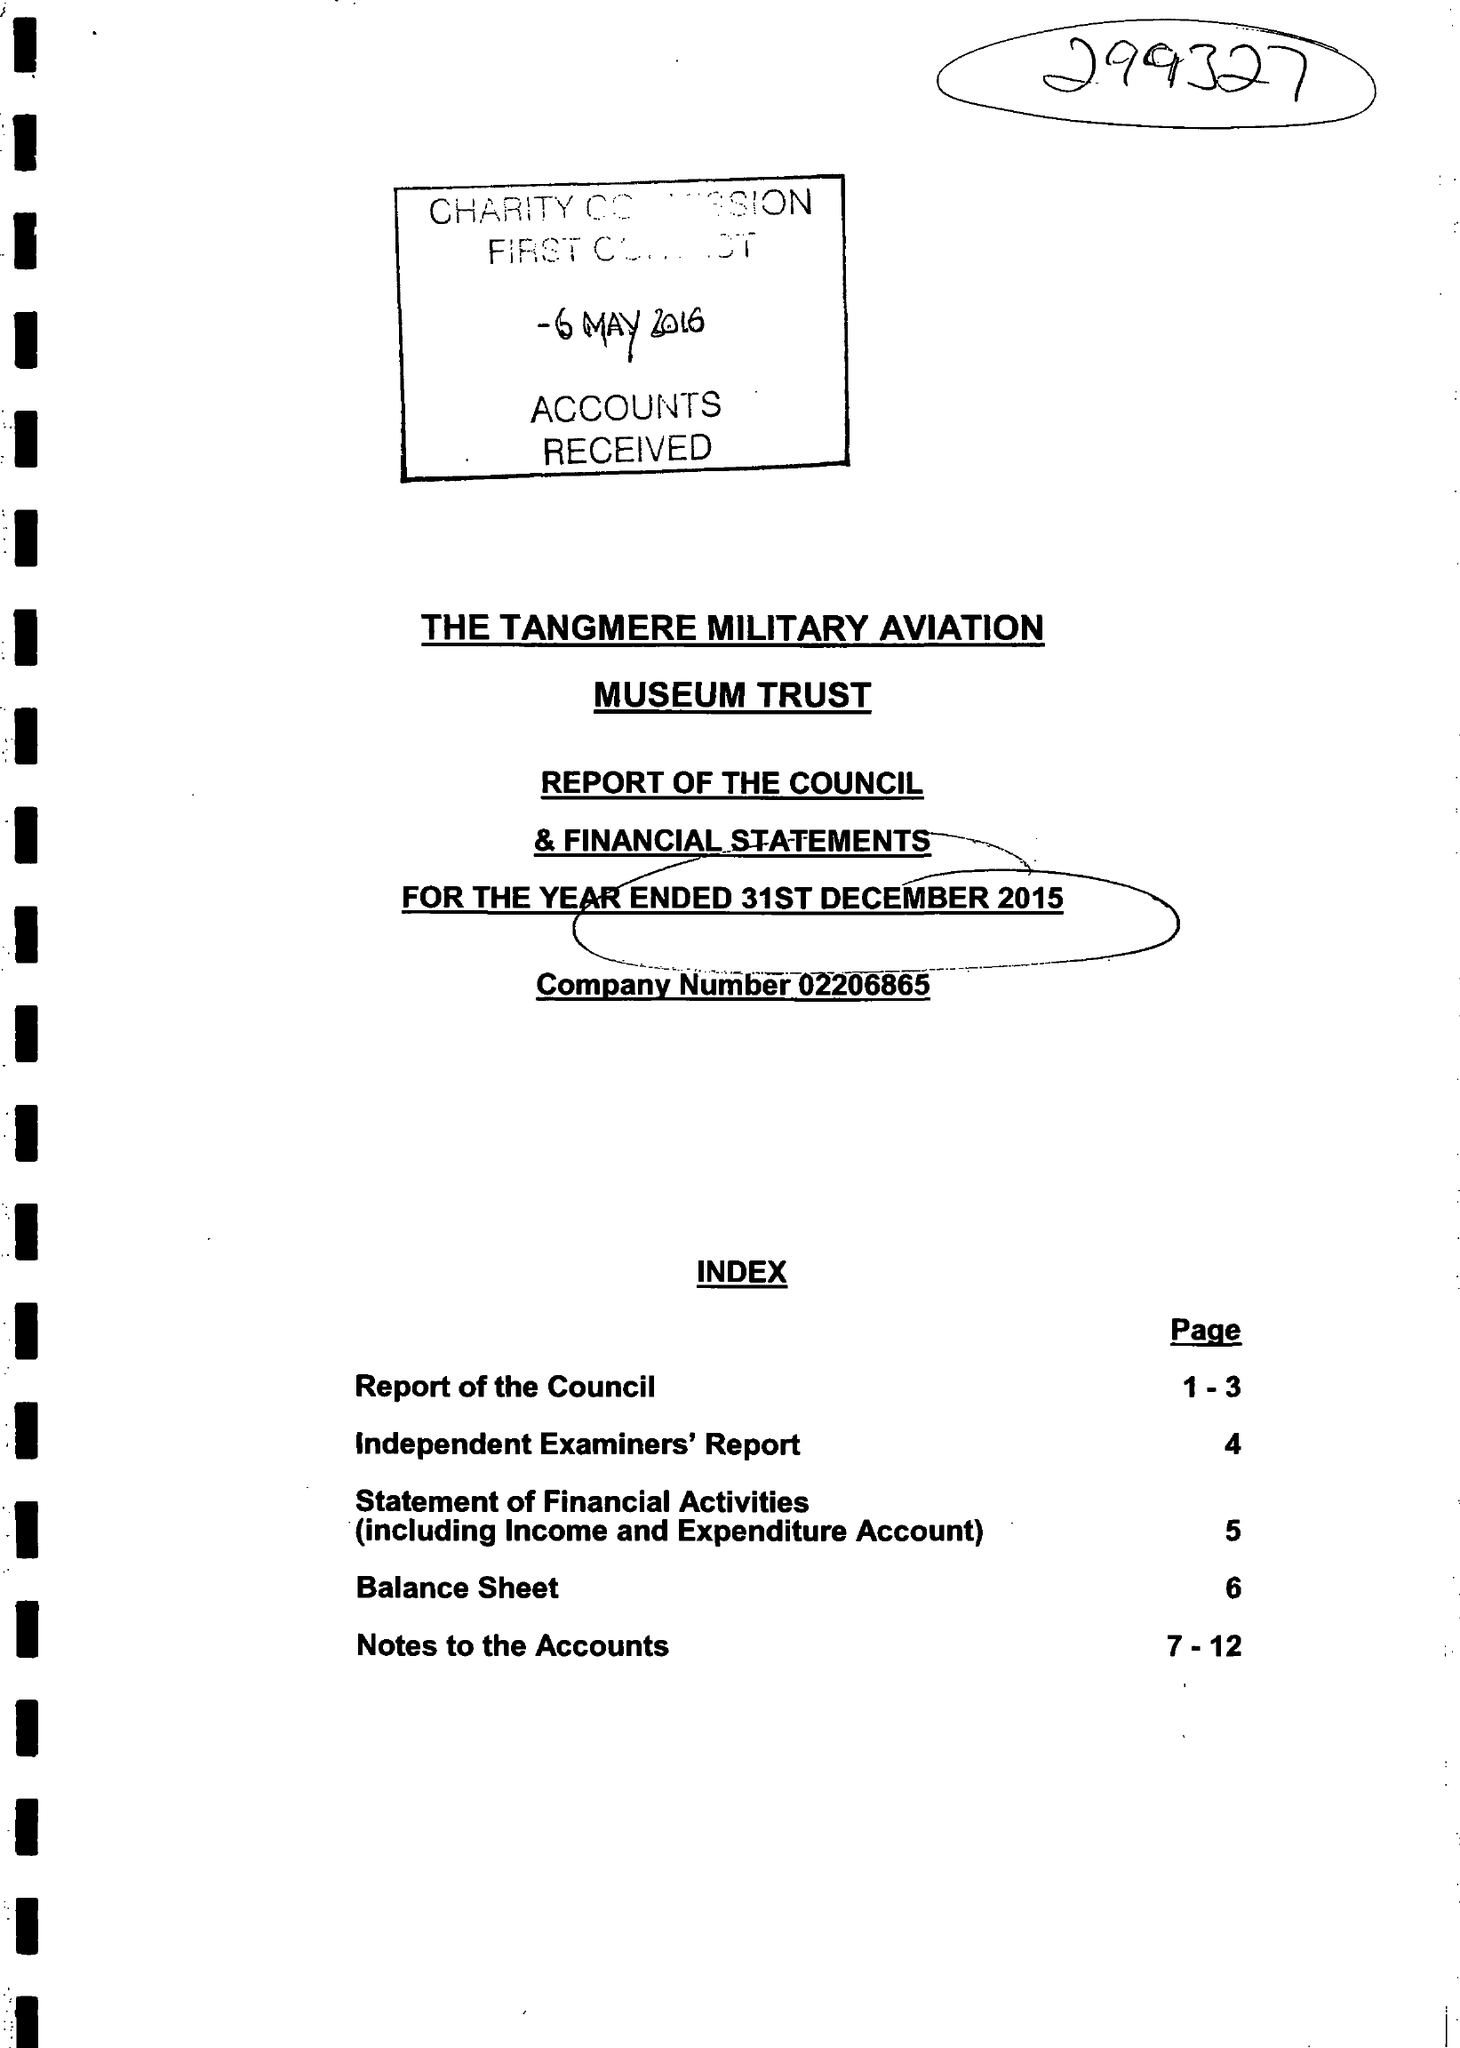What is the value for the address__post_town?
Answer the question using a single word or phrase. None 